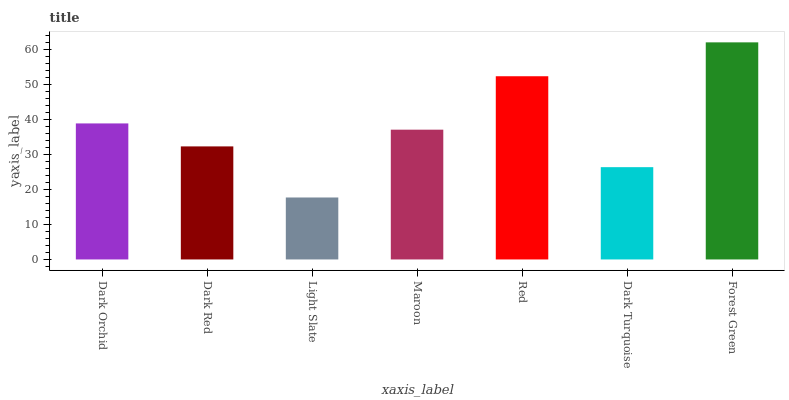Is Light Slate the minimum?
Answer yes or no. Yes. Is Forest Green the maximum?
Answer yes or no. Yes. Is Dark Red the minimum?
Answer yes or no. No. Is Dark Red the maximum?
Answer yes or no. No. Is Dark Orchid greater than Dark Red?
Answer yes or no. Yes. Is Dark Red less than Dark Orchid?
Answer yes or no. Yes. Is Dark Red greater than Dark Orchid?
Answer yes or no. No. Is Dark Orchid less than Dark Red?
Answer yes or no. No. Is Maroon the high median?
Answer yes or no. Yes. Is Maroon the low median?
Answer yes or no. Yes. Is Dark Orchid the high median?
Answer yes or no. No. Is Dark Turquoise the low median?
Answer yes or no. No. 